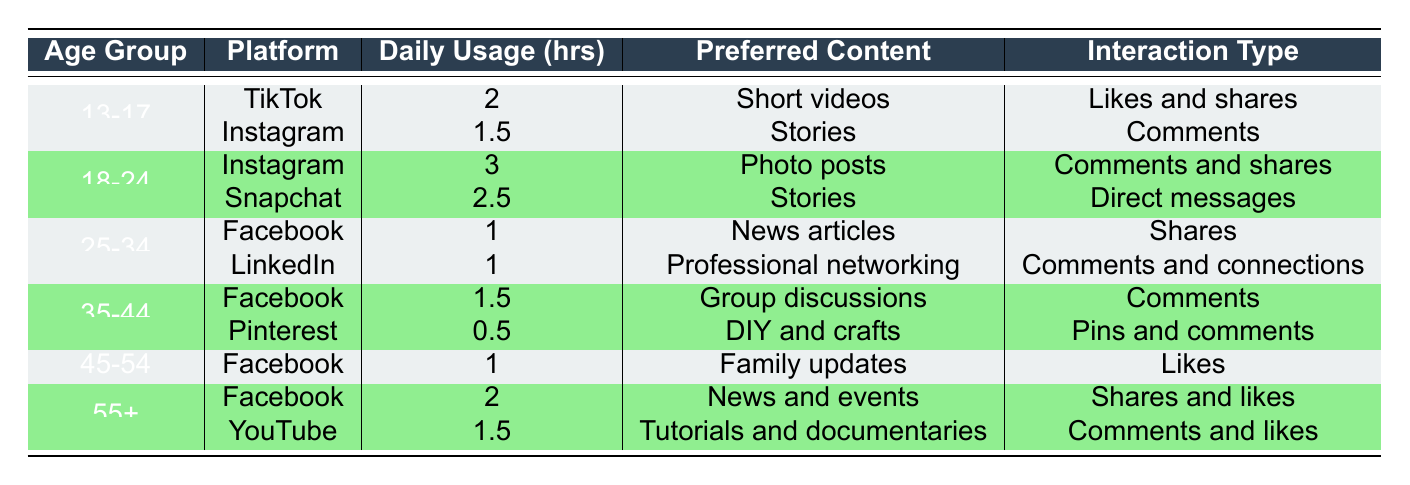What is the most popular platform for the age group 18-24? Looking at the table, the popular platforms for the age group 18-24 are Instagram and Snapchat. Instagram has the highest daily usage hours at 3, compared to Snapchat's 2.5. Thus, Instagram is the most popular platform for this age group.
Answer: Instagram How many hours do users aged 35-44 spend on Facebook daily? In the table, the age group 35-44 uses Facebook for 1.5 hours daily. This is specified in the row dedicated to Facebook under this age group.
Answer: 1.5 hours Is the daily usage of TikTok by the 13-17 age group greater than that of Instagram by the same group? TikTok's daily usage for the 13-17 age group is 2 hours, while Instagram's usage is 1.5 hours. Since 2 is greater than 1.5, the statement is true.
Answer: Yes What is the total daily usage time of social media platforms for users aged 55 and older? The daily usage for this age group includes Facebook (2 hours) and YouTube (1.5 hours). To find the total, we sum these values: 2 + 1.5 = 3.5. Therefore, the total daily usage for users aged 55 and older is 3.5 hours.
Answer: 3.5 hours Which age group spends the least amount of time on social media? In the table, the age group 35-44 has Pinterest listed with the lowest daily usage at 0.5 hours. Thus, this age group is the one that spends the least time on social media, specifically on Pinterest.
Answer: 35-44 age group What is the average daily usage hours of the platforms preferred by the 25-34 age group? The daily usage for the 25-34 age group comprises Facebook (1 hour) and LinkedIn (1 hour). The sum of these is 1 + 1 = 2. To find the average, divide by the number of platforms (2), which gives 2/2 = 1. Therefore, the average daily usage hours for this age group is 1.
Answer: 1 hour Do users aged 45-54 primarily use Facebook? The table shows that the only platform listed for the 45-54 age group is Facebook, which indicates that users in this age group do indeed primarily use Facebook.
Answer: Yes How many different platforms do users aged 18-24 engage with? Users in the 18-24 age group are active on two platforms, which are Instagram and Snapchat. Therefore, the total number of different platforms for this age group is two.
Answer: 2 platforms 